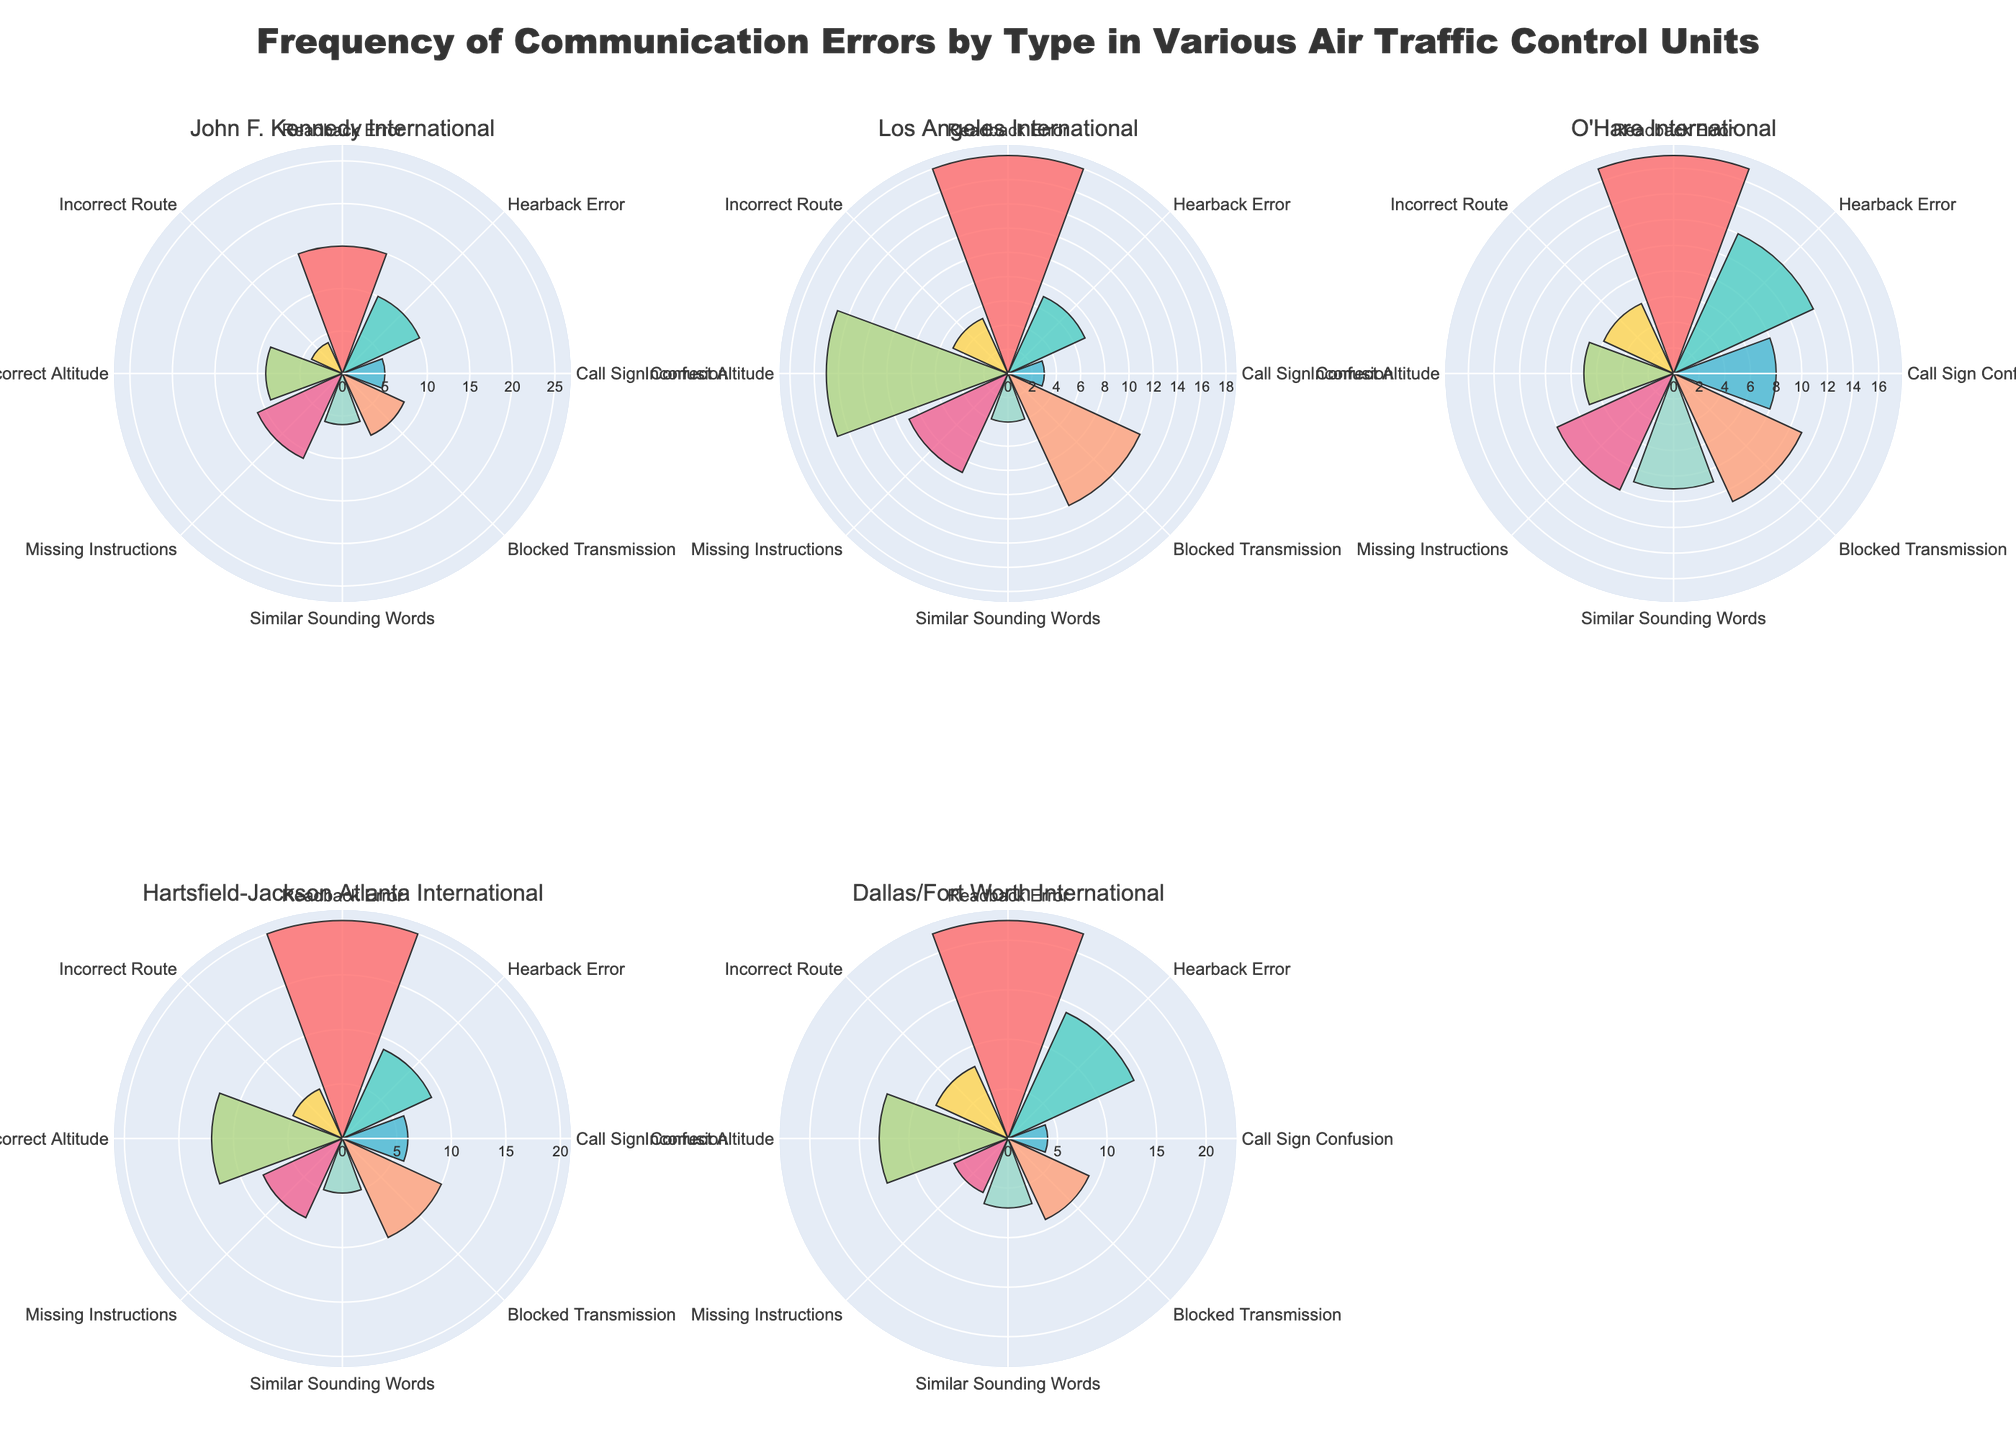which airport has the highest number of 'Readback Error' incidents? The 'Readback Error' slices in the rose charts can be compared for all airports. The highest value slice represents the airport with the most incidents. John F. Kennedy International has 15, Los Angeles International has 18, O'Hare International has 17, Hartsfield-Jackson Atlanta International has 20, and Dallas/Fort Worth International has 22.
Answer: Dallas/Fort Worth International which communication error type has the lowest occurrences at Los Angeles International Airport? By analyzing the length of slices in the Los Angeles International rose chart, we can identify the error type with the smallest value. 'Call Sign Confusion' has the slice with the smallest value of 3.
Answer: Call Sign Confusion What is the total number of 'Incorrect Altitude' incidents across all airports? Sum the values for 'Incorrect Altitude' from each of the airports: John F. Kennedy International (9) + Los Angeles International (15) + O'Hare International (7) + Hartsfield-Jackson Atlanta International (12) + Dallas/Fort Worth International (13). The total is 9 + 15 + 7 + 12 + 13 = 56.
Answer: 56 Which airport has the most balanced (least disparity) distribution of error types? The airport with the most balanced distribution will have slices of similar lengths across the rose chart. By visually comparing the rose charts, O'Hare International appears to have the most balanced distribution as its slices are most uniform.
Answer: O'Hare International How many more 'Hearback Error' incidents are there at Dallas/Fort Worth International compared to Los Angeles International? Subtract the number of 'Hearback Error' incidents at Los Angeles International (7) from the number at Dallas/Fort Worth International (14): 14 - 7.
Answer: 7 How does the frequency of 'Blocked Transmission' at John F. Kennedy International compare to O'Hare International? Compare the lengths of the 'Blocked Transmission' slices for both airports. John F. Kennedy International has a value of 8, while O'Hare International has a value of 11.
Answer: O'Hare International has more Which communication error type has the highest incidents at Hartsfield-Jackson Atlanta International Airport? Locate the longest slice in the rose chart for Hartsfield-Jackson Atlanta International. The longest slice corresponds to 'Readback Error' with a count of 20.
Answer: Readback Error What is the average number of 'Similar Sounding Words' incidents across all airports? Sum the incidents of 'Similar Sounding Words' across the airports and divide by the number of airports: (6 + 4 + 9 + 5 + 7) / 5 = 31 / 5.
Answer: 6.2 Which error types are tied for the highest frequency at Los Angeles International Airport? Examine the rose chart for Los Angeles International to identify the longest slices. Both 'Readback Error' and 'Incorrect Altitude' have the highest counts at 18 and 15, respectively.
Answer: Readback Error and Incorrect Altitude 